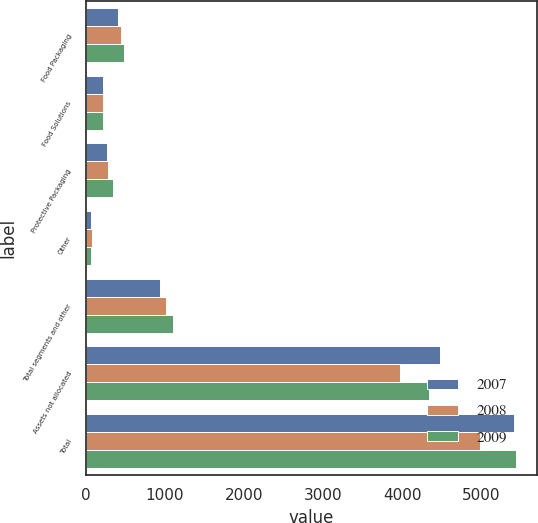Convert chart to OTSL. <chart><loc_0><loc_0><loc_500><loc_500><stacked_bar_chart><ecel><fcel>Food Packaging<fcel>Food Solutions<fcel>Protective Packaging<fcel>Other<fcel>Total segments and other<fcel>Assets not allocated<fcel>Total<nl><fcel>2007<fcel>401.2<fcel>210.6<fcel>266.1<fcel>57.9<fcel>935.8<fcel>4484.3<fcel>5420.1<nl><fcel>2008<fcel>443.1<fcel>216.6<fcel>281.2<fcel>72.5<fcel>1013.4<fcel>3972.6<fcel>4986<nl><fcel>2009<fcel>476.4<fcel>215.1<fcel>337.5<fcel>69.5<fcel>1098.5<fcel>4339.8<fcel>5438.3<nl></chart> 